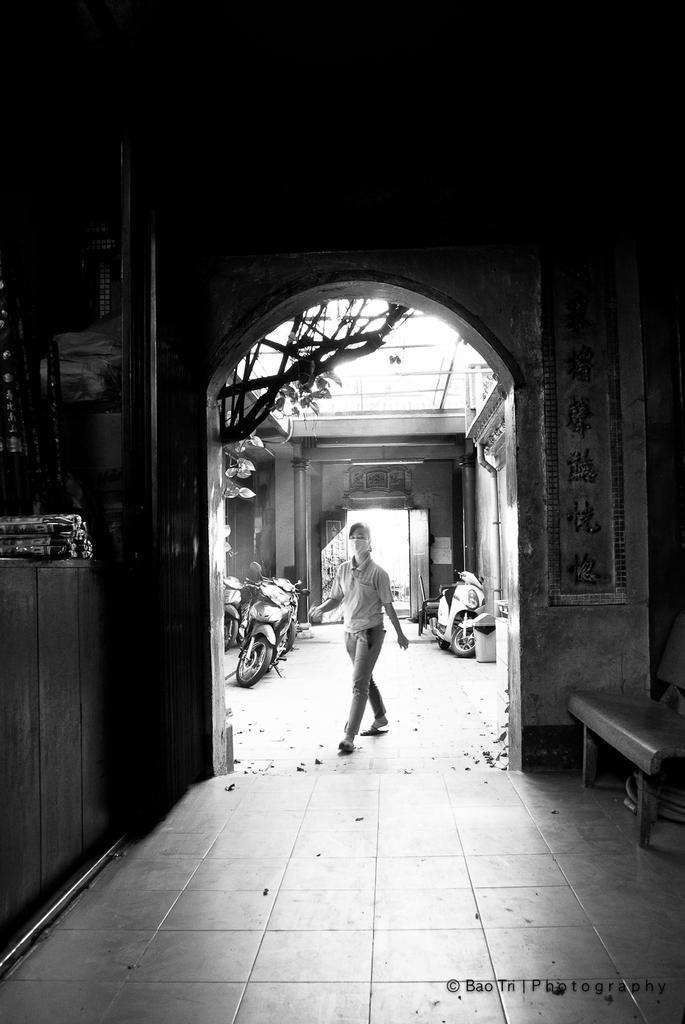In one or two sentences, can you explain what this image depicts? In this picture there is a bench on the right side of the image and there is a desk on the left side of the image, on which there are boxes and polythene bags, there is a door in the center of the image, there are bikes and trees outside the door and there is a lady in the center of the image, in front of a door. 